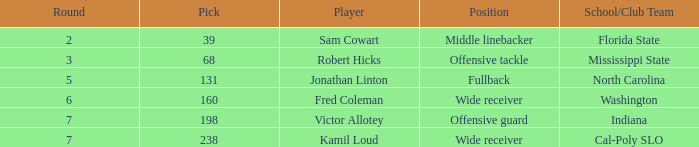Which Round has a School/Club Team of indiana, and a Pick smaller than 198? None. 